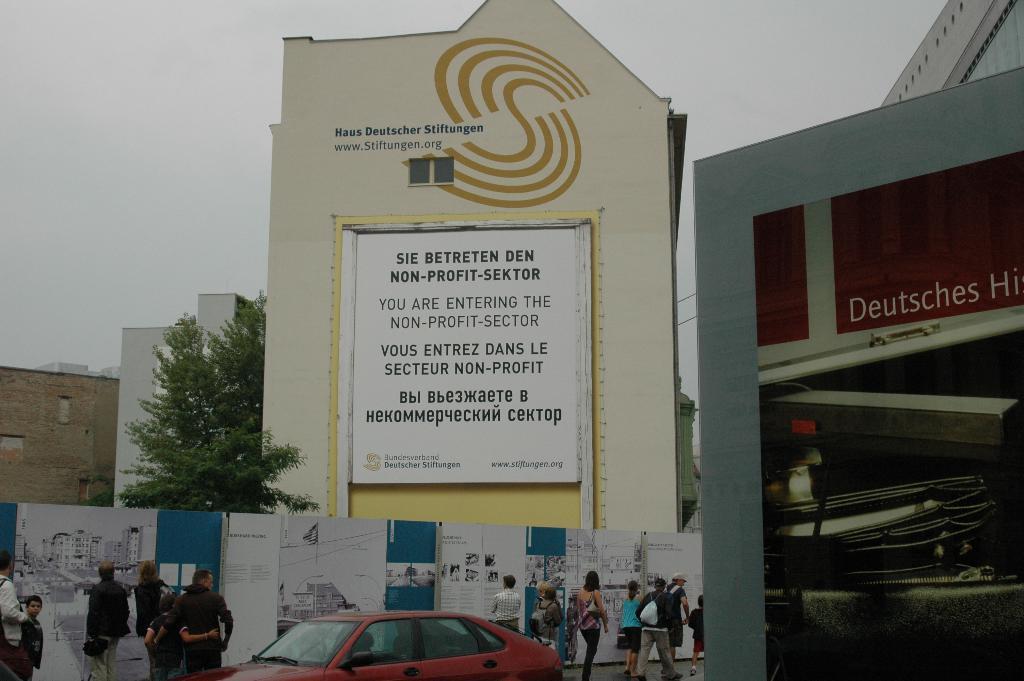Could you give a brief overview of what you see in this image? In this image I can see a car, few persons, the wall and few banners to the wall. I can see few trees and few buildings. In the background I can see the sky. 